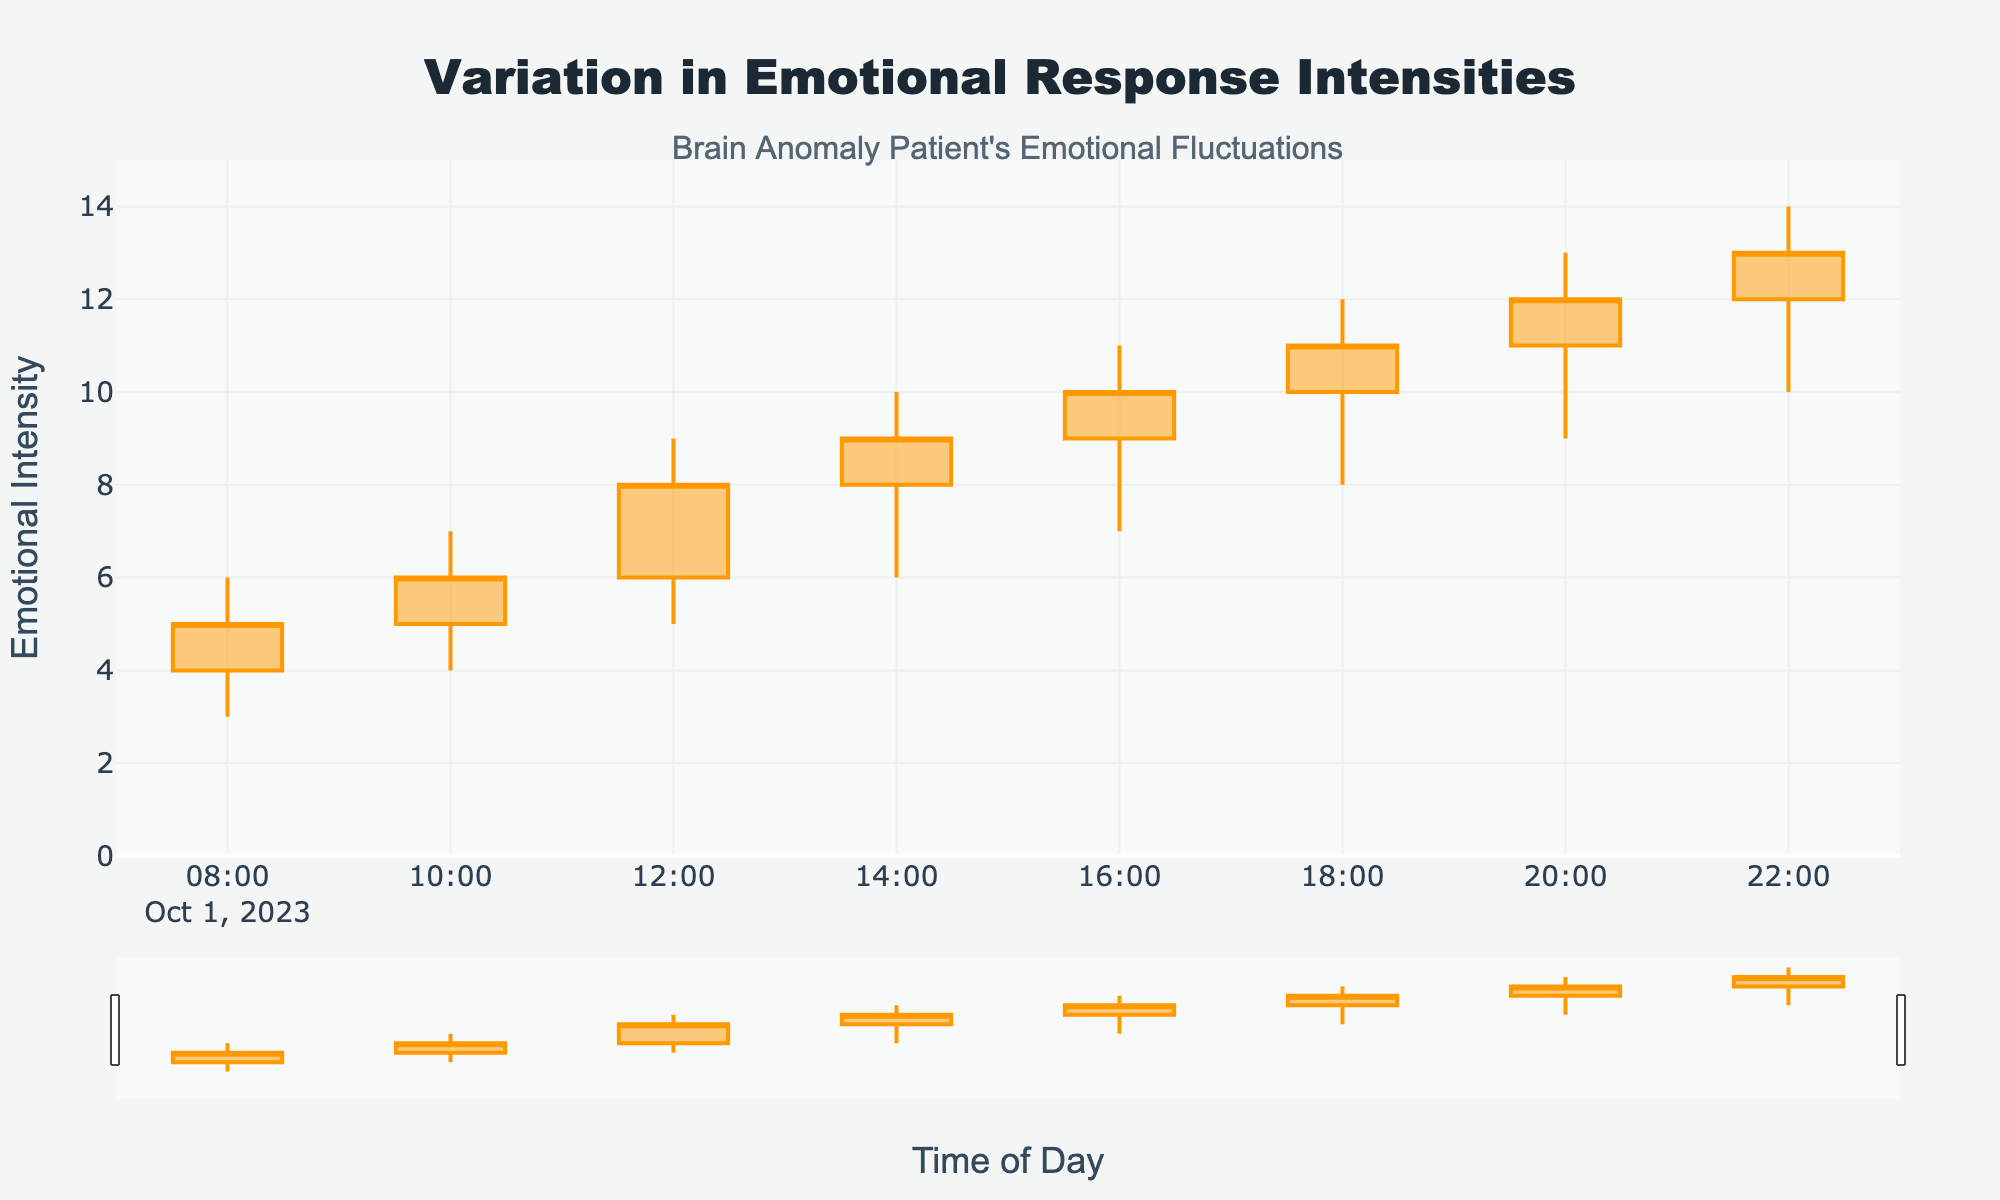How does the title describe the figure? The title of the figure is "Variation in Emotional Response Intensities," indicating that the plot shows changes in emotional response levels throughout the day.
Answer: It describes changes in emotional response levels throughout the day Which time interval shows the highest emotional intensity for the day? The highest emotional intensity is given by the highest "High" value on the y-axis. The highest value is 14, occurring at the 22:00 mark.
Answer: 22:00 What's the difference between the highest and lowest emotional intensities at 18:00? At 18:00, the high value is 12 and the low value is 8. The difference is calculated as 12 - 8 = 4.
Answer: 4 How many time intervals show an increase in the emotional intensity from open to close? To determine this, check where close values are higher than open values. This is true for all time intervals (08:00, 10:00, 12:00, 14:00, 16:00, 18:00, 20:00, and 22:00).
Answer: 8 Which time interval had the smallest range in emotional intensity? The range is calculated as the difference between the high and low values of each time interval. Calculate all ranges and find the smallest:
08:00: 6 - 3 = 3
10:00: 7 - 4 = 3
12:00: 9 - 5 = 4
14:00: 10 - 6 = 4
16:00: 11 - 7 = 4
18:00: 12 - 8 = 4
20:00: 13 - 9 = 4
22:00: 14 - 10 = 4
The smallest range occurs at 08:00 and 10:00.
Answer: 08:00 and 10:00 What is the average emotional intensity at the close of each interval? To find the average of the close values: (5 + 6 + 8 + 9 + 10 + 11 + 12 + 13)/8 = 74/8 = 9.25.
Answer: 9.25 At which time interval does the first significant increase in emotional intensity occur? Compare the close values from one interval to the next. The first significant increase occurs when moving from 08:00 (close = 5) to 10:00 (close = 6), but magnitude matters more. The largest first increase seems at 12:00 (close = 8) from 10:00 (close = 6).
Answer: 12:00 How does the color scheme indicate changes in emotional response intensities? Increasing emotional intensities have an orange color, while decreasing intensities have a dark brown color, helping to distinguish between positive and negative emotional changes.
Answer: Orange for increasing and dark brown for decreasing What annotations are present in the figure, and what do they indicate? The figure has an annotation that reads "Brain Anomaly Patient's Emotional Fluctuations," providing context about the source or subject of the data represented.
Answer: "Brain Anomaly Patient's Emotional Fluctuations" 